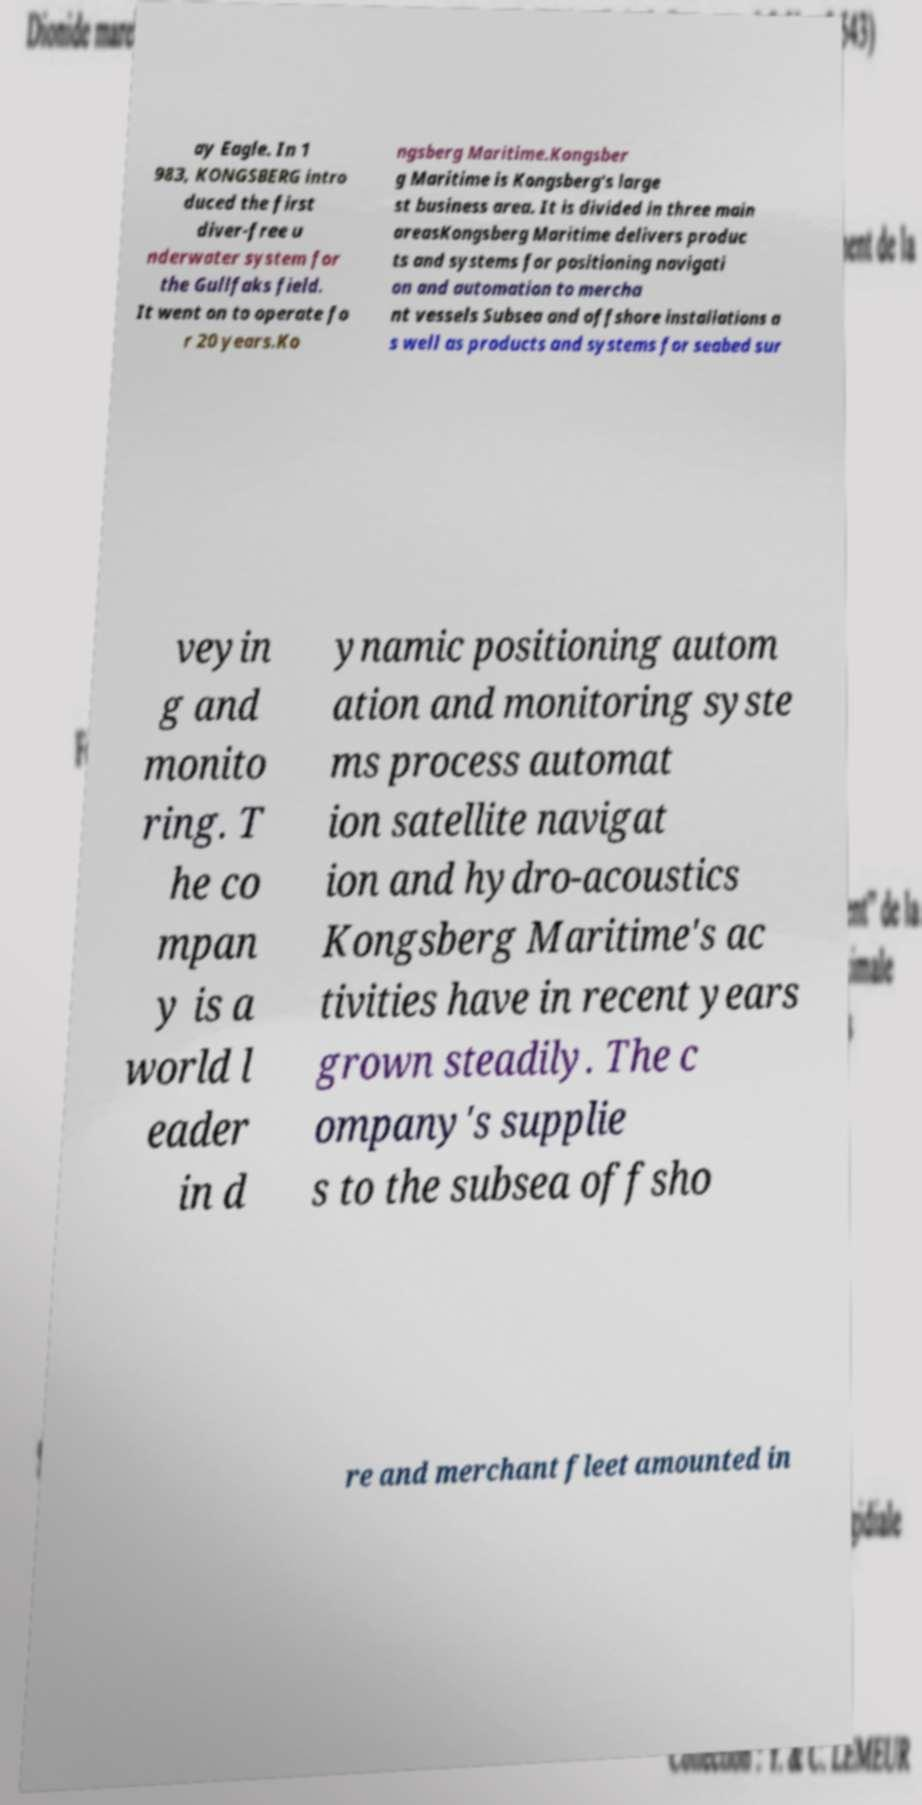Could you assist in decoding the text presented in this image and type it out clearly? ay Eagle. In 1 983, KONGSBERG intro duced the first diver-free u nderwater system for the Gullfaks field. It went on to operate fo r 20 years.Ko ngsberg Maritime.Kongsber g Maritime is Kongsberg's large st business area. It is divided in three main areasKongsberg Maritime delivers produc ts and systems for positioning navigati on and automation to mercha nt vessels Subsea and offshore installations a s well as products and systems for seabed sur veyin g and monito ring. T he co mpan y is a world l eader in d ynamic positioning autom ation and monitoring syste ms process automat ion satellite navigat ion and hydro-acoustics Kongsberg Maritime's ac tivities have in recent years grown steadily. The c ompany's supplie s to the subsea offsho re and merchant fleet amounted in 